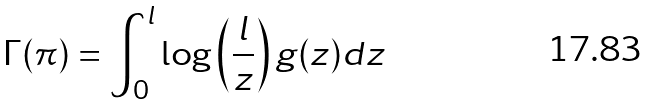Convert formula to latex. <formula><loc_0><loc_0><loc_500><loc_500>\Gamma ( \pi ) = \int _ { 0 } ^ { l } \log \left ( \frac { l } { z } \right ) g ( z ) d z</formula> 